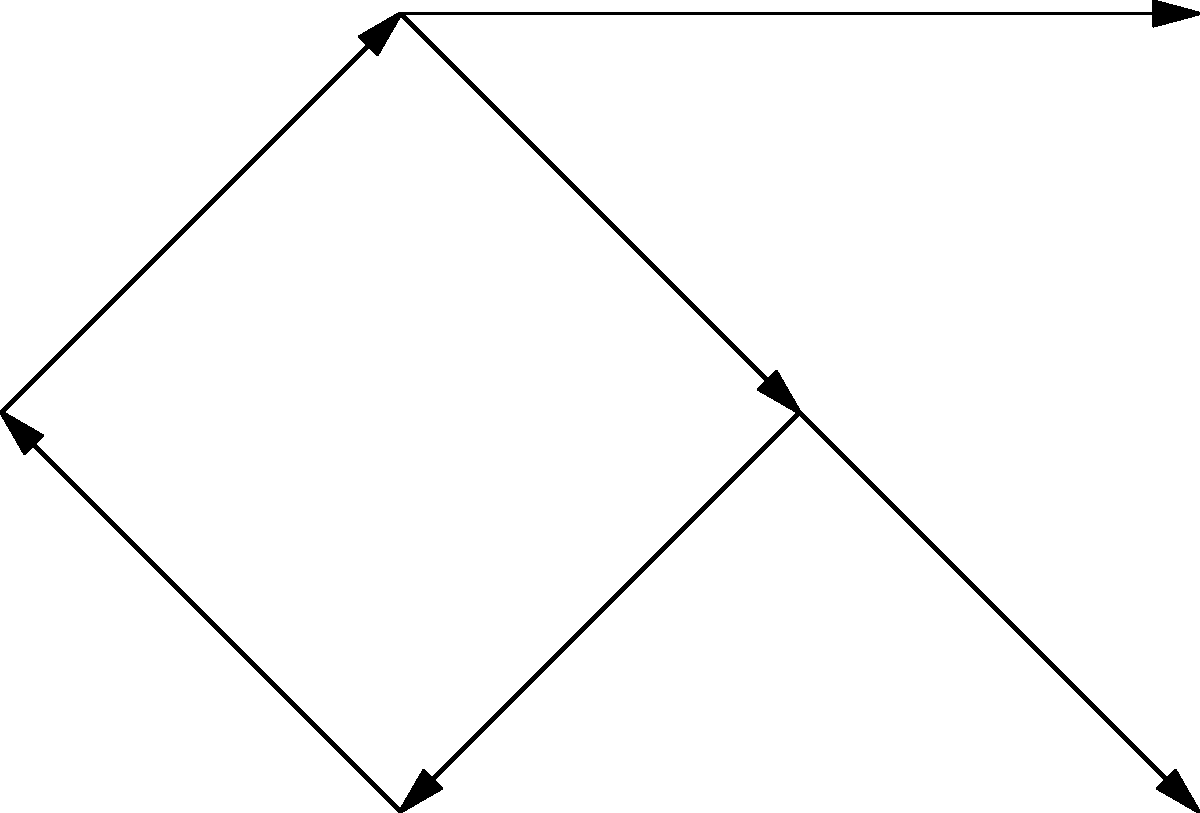In the given graph representing callback relationships in asynchronous JavaScript code, where each node represents a function and each directed edge represents a callback, identify the number of cycles present. Assume that a cycle occurs when a series of callbacks eventually leads back to the original function. To identify cycles in this graph, we need to follow these steps:

1. Start from each node and follow the directed edges.
2. Keep track of visited nodes.
3. If we encounter a node that has already been visited, we have found a cycle.

Let's analyze the graph:

1. Starting from f1:
   f1 → f2 → f3 → f4 → f1
   This forms a cycle (f1 → f2 → f3 → f4 → f1)

2. Starting from f2:
   f2 → f3 → f4 → f1 → f2
   This is the same cycle as above, rotated

3. Starting from f3:
   f3 → f4 → f1 → f2 → f3
   Again, this is the same cycle

4. Starting from f4:
   f4 → f1 → f2 → f3 → f4
   Once more, this is the same cycle

5. Starting from f5:
   f5 has no outgoing edges, so it doesn't form any cycles

6. Starting from f6:
   f6 also has no outgoing edges, so it doesn't form any cycles

After analyzing all nodes, we can conclude that there is only one unique cycle in this graph, which involves nodes f1, f2, f3, and f4.
Answer: 1 